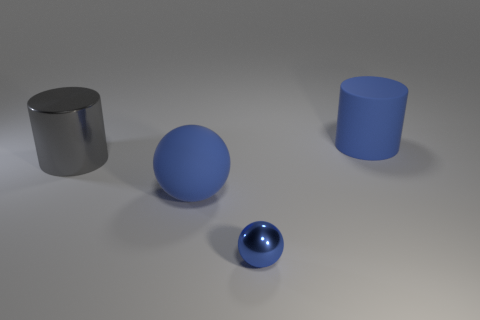Add 2 tiny gray rubber cylinders. How many objects exist? 6 Add 2 blue matte things. How many blue matte things are left? 4 Add 1 tiny blue shiny balls. How many tiny blue shiny balls exist? 2 Subtract 0 gray cubes. How many objects are left? 4 Subtract all blue metal balls. Subtract all tiny rubber objects. How many objects are left? 3 